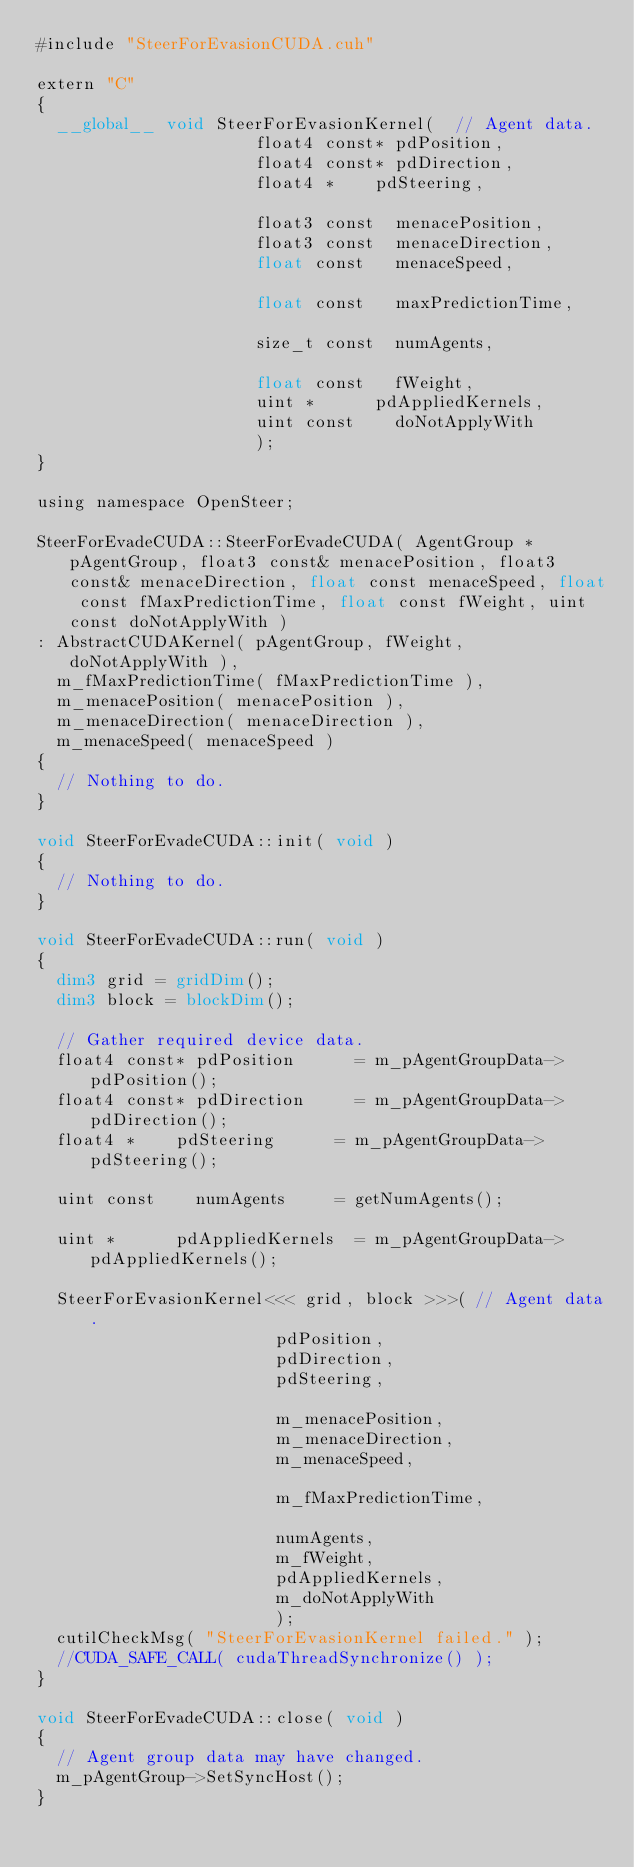Convert code to text. <code><loc_0><loc_0><loc_500><loc_500><_Cuda_>#include "SteerForEvasionCUDA.cuh"

extern "C"
{
	__global__ void SteerForEvasionKernel(	// Agent data.
											float4 const*	pdPosition,
											float4 const*	pdDirection,
											float4 *		pdSteering,

											float3 const	menacePosition,
											float3 const	menaceDirection,
											float const		menaceSpeed,
											
											float const		maxPredictionTime,

											size_t const	numAgents,

											float const		fWeight,
											uint *			pdAppliedKernels,
											uint const		doNotApplyWith
										  );
}

using namespace OpenSteer;

SteerForEvadeCUDA::SteerForEvadeCUDA( AgentGroup * pAgentGroup, float3 const& menacePosition, float3 const& menaceDirection, float const menaceSpeed, float const fMaxPredictionTime, float const fWeight, uint const doNotApplyWith )
:	AbstractCUDAKernel( pAgentGroup, fWeight, doNotApplyWith ),
	m_fMaxPredictionTime( fMaxPredictionTime ),
	m_menacePosition( menacePosition ),
	m_menaceDirection( menaceDirection ),
	m_menaceSpeed( menaceSpeed )
{
	// Nothing to do.
}

void SteerForEvadeCUDA::init( void )
{
	// Nothing to do.
}

void SteerForEvadeCUDA::run( void )
{
	dim3 grid = gridDim();
	dim3 block = blockDim();

	// Gather required device data.
	float4 const*	pdPosition			= m_pAgentGroupData->pdPosition();
	float4 const*	pdDirection			= m_pAgentGroupData->pdDirection();
	float4 *		pdSteering			= m_pAgentGroupData->pdSteering();

	uint const		numAgents			= getNumAgents();

	uint *			pdAppliedKernels	= m_pAgentGroupData->pdAppliedKernels();

	SteerForEvasionKernel<<< grid, block >>>(	// Agent data.
												pdPosition,
												pdDirection,
												pdSteering,

												m_menacePosition,
												m_menaceDirection,
												m_menaceSpeed,

												m_fMaxPredictionTime,

												numAgents,
												m_fWeight,
												pdAppliedKernels,
												m_doNotApplyWith
												);
	cutilCheckMsg( "SteerForEvasionKernel failed." );
	//CUDA_SAFE_CALL( cudaThreadSynchronize() );
}

void SteerForEvadeCUDA::close( void )
{
	// Agent group data may have changed.
	m_pAgentGroup->SetSyncHost();
}
</code> 